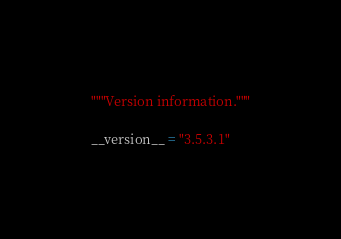Convert code to text. <code><loc_0><loc_0><loc_500><loc_500><_Python_>"""Version information."""

__version__ = "3.5.3.1"
</code> 